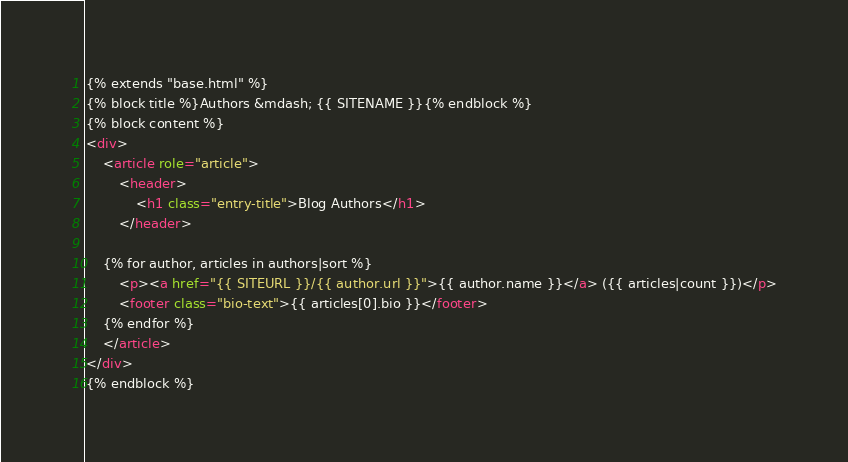<code> <loc_0><loc_0><loc_500><loc_500><_HTML_>{% extends "base.html" %}
{% block title %}Authors &mdash; {{ SITENAME }}{% endblock %}
{% block content %}
<div>
	<article role="article">
    	<header>
    		<h1 class="entry-title">Blog Authors</h1>
    	</header>

	{% for author, articles in authors|sort %}
		<p><a href="{{ SITEURL }}/{{ author.url }}">{{ author.name }}</a> ({{ articles|count }})</p>
		<footer class="bio-text">{{ articles[0].bio }}</footer>
	{% endfor %}
	</article>
</div>
{% endblock %}
</code> 